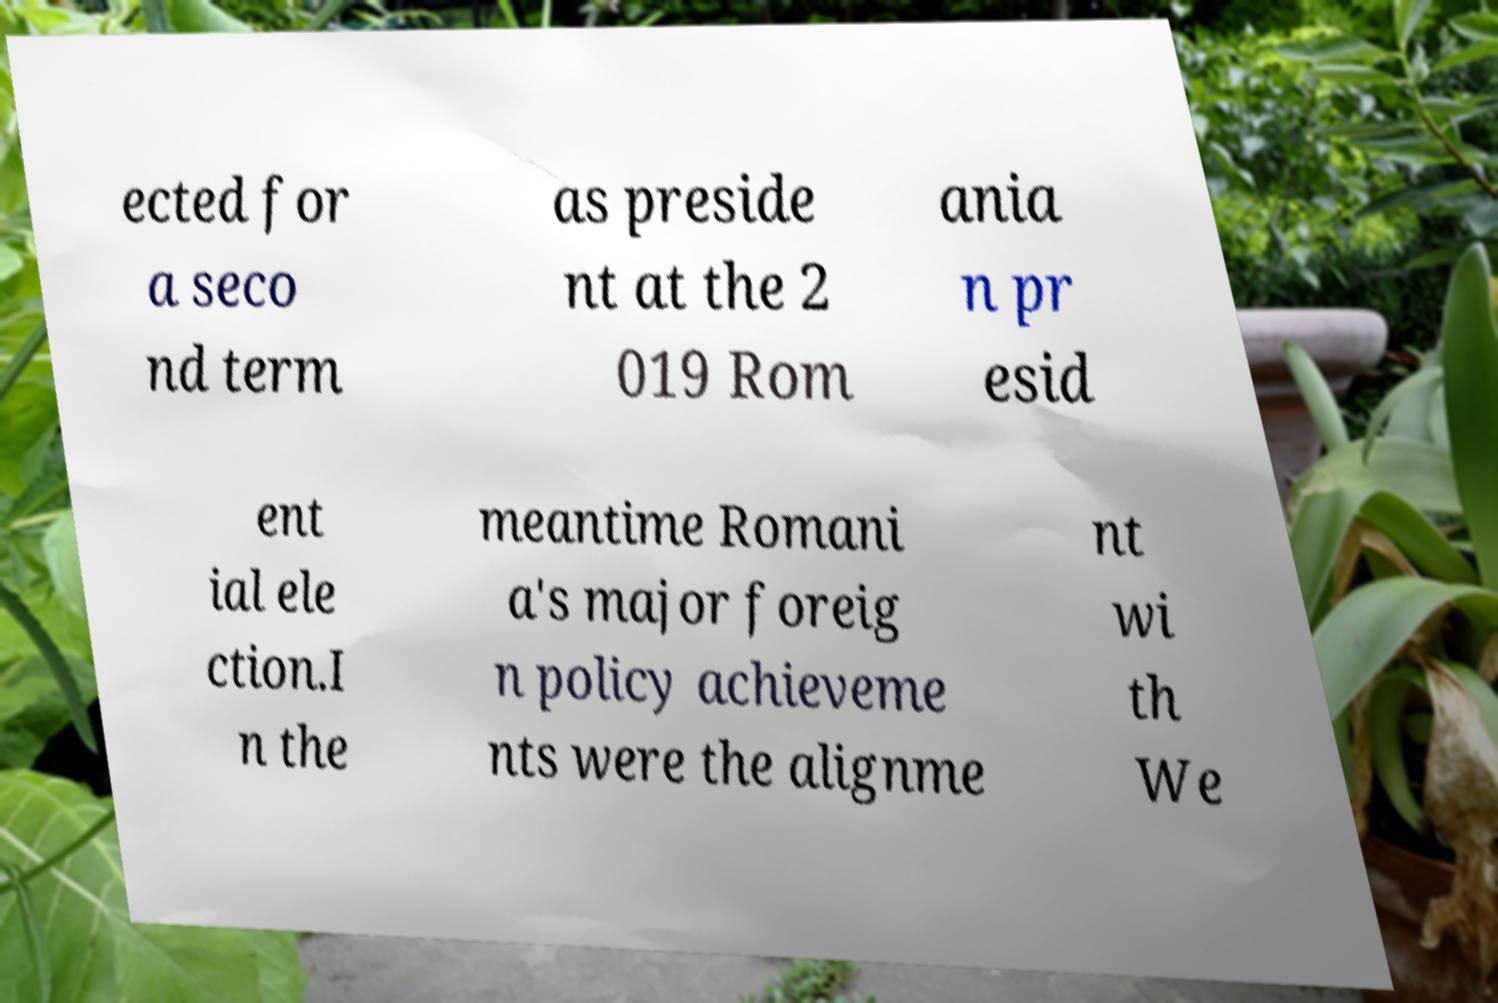Could you extract and type out the text from this image? ected for a seco nd term as preside nt at the 2 019 Rom ania n pr esid ent ial ele ction.I n the meantime Romani a's major foreig n policy achieveme nts were the alignme nt wi th We 